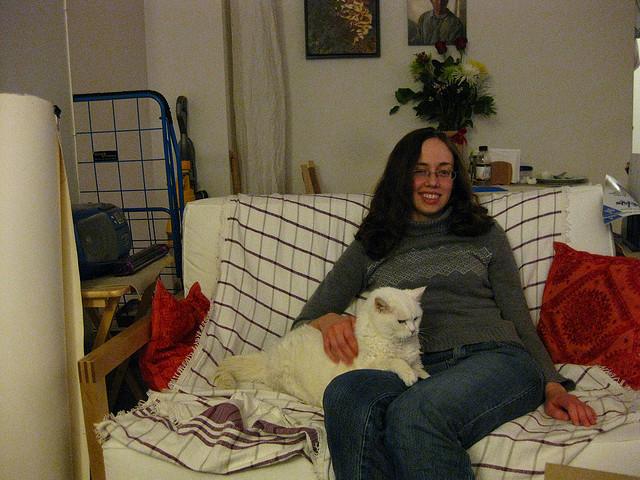Is the lady reading a magazine?
Be succinct. No. Is the room a mess?
Quick response, please. Yes. Does this woman like her cat?
Be succinct. Yes. What room is behind the couch?
Keep it brief. Dining room. What color is this person's sweater?
Short answer required. Gray. What is her top called?
Keep it brief. Sweater. How many red pillows are there?
Short answer required. 2. What color is the cat?
Short answer required. White. What color trim is on the seat cushions?
Concise answer only. White. Is the cat on a woman?
Concise answer only. Yes. What are the orange objects?
Answer briefly. Pillows. 